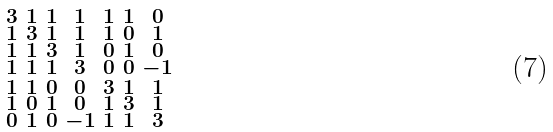<formula> <loc_0><loc_0><loc_500><loc_500>\begin{smallmatrix} 3 & 1 & 1 & 1 & 1 & 1 & 0 \\ 1 & 3 & 1 & 1 & 1 & 0 & 1 \\ 1 & 1 & 3 & 1 & 0 & 1 & 0 \\ 1 & 1 & 1 & 3 & 0 & 0 & - 1 \\ 1 & 1 & 0 & 0 & 3 & 1 & 1 \\ 1 & 0 & 1 & 0 & 1 & 3 & 1 \\ 0 & 1 & 0 & - 1 & 1 & 1 & 3 \end{smallmatrix}</formula> 